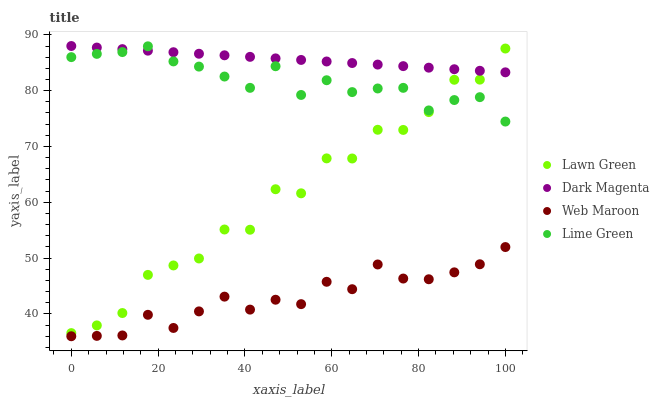Does Web Maroon have the minimum area under the curve?
Answer yes or no. Yes. Does Dark Magenta have the maximum area under the curve?
Answer yes or no. Yes. Does Dark Magenta have the minimum area under the curve?
Answer yes or no. No. Does Web Maroon have the maximum area under the curve?
Answer yes or no. No. Is Dark Magenta the smoothest?
Answer yes or no. Yes. Is Lawn Green the roughest?
Answer yes or no. Yes. Is Web Maroon the smoothest?
Answer yes or no. No. Is Web Maroon the roughest?
Answer yes or no. No. Does Web Maroon have the lowest value?
Answer yes or no. Yes. Does Dark Magenta have the lowest value?
Answer yes or no. No. Does Dark Magenta have the highest value?
Answer yes or no. Yes. Does Web Maroon have the highest value?
Answer yes or no. No. Is Web Maroon less than Lawn Green?
Answer yes or no. Yes. Is Lawn Green greater than Web Maroon?
Answer yes or no. Yes. Does Lime Green intersect Dark Magenta?
Answer yes or no. Yes. Is Lime Green less than Dark Magenta?
Answer yes or no. No. Is Lime Green greater than Dark Magenta?
Answer yes or no. No. Does Web Maroon intersect Lawn Green?
Answer yes or no. No. 